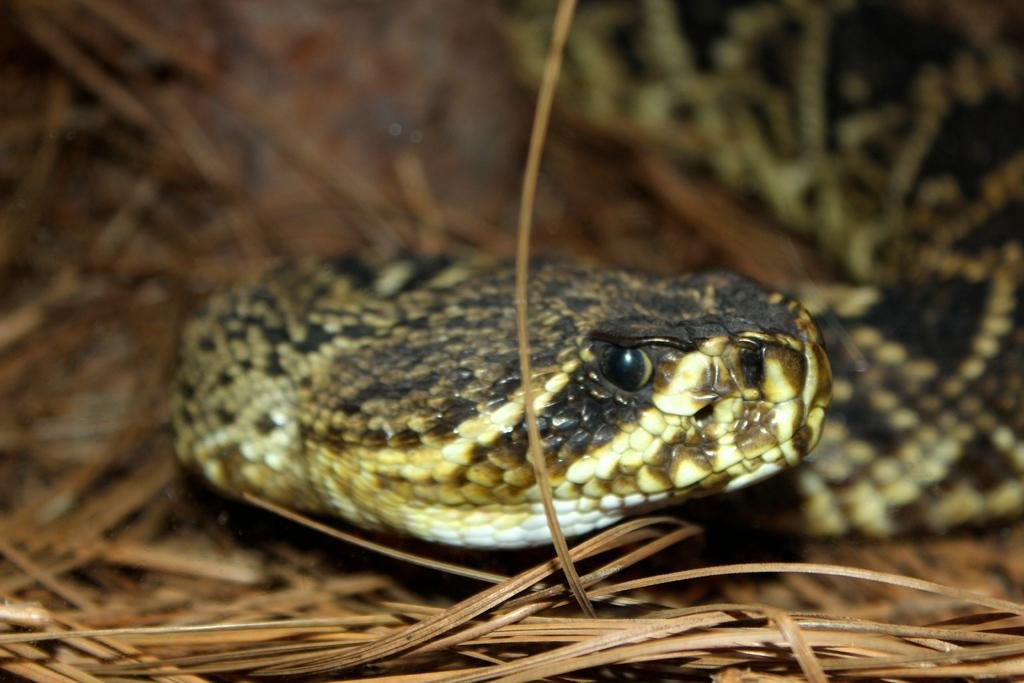What is the main subject in the center of the image? There is a snake in the center of the image. What type of vegetation can be seen at the bottom of the image? There is grass visible at the bottom of the image. What type of fiction is the snake reading in the image? There is no indication in the image that the snake is reading any fiction, as snakes do not have the ability to read. 